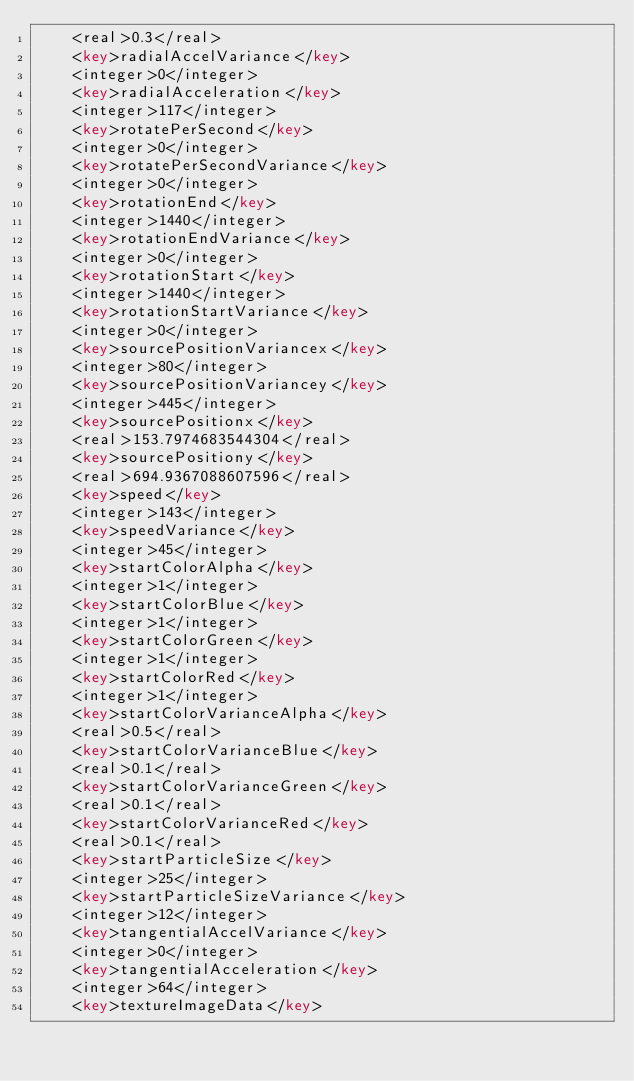Convert code to text. <code><loc_0><loc_0><loc_500><loc_500><_XML_>    <real>0.3</real>
    <key>radialAccelVariance</key>
    <integer>0</integer>
    <key>radialAcceleration</key>
    <integer>117</integer>
    <key>rotatePerSecond</key>
    <integer>0</integer>
    <key>rotatePerSecondVariance</key>
    <integer>0</integer>
    <key>rotationEnd</key>
    <integer>1440</integer>
    <key>rotationEndVariance</key>
    <integer>0</integer>
    <key>rotationStart</key>
    <integer>1440</integer>
    <key>rotationStartVariance</key>
    <integer>0</integer>
    <key>sourcePositionVariancex</key>
    <integer>80</integer>
    <key>sourcePositionVariancey</key>
    <integer>445</integer>
    <key>sourcePositionx</key>
    <real>153.7974683544304</real>
    <key>sourcePositiony</key>
    <real>694.9367088607596</real>
    <key>speed</key>
    <integer>143</integer>
    <key>speedVariance</key>
    <integer>45</integer>
    <key>startColorAlpha</key>
    <integer>1</integer>
    <key>startColorBlue</key>
    <integer>1</integer>
    <key>startColorGreen</key>
    <integer>1</integer>
    <key>startColorRed</key>
    <integer>1</integer>
    <key>startColorVarianceAlpha</key>
    <real>0.5</real>
    <key>startColorVarianceBlue</key>
    <real>0.1</real>
    <key>startColorVarianceGreen</key>
    <real>0.1</real>
    <key>startColorVarianceRed</key>
    <real>0.1</real>
    <key>startParticleSize</key>
    <integer>25</integer>
    <key>startParticleSizeVariance</key>
    <integer>12</integer>
    <key>tangentialAccelVariance</key>
    <integer>0</integer>
    <key>tangentialAcceleration</key>
    <integer>64</integer>
    <key>textureImageData</key></code> 